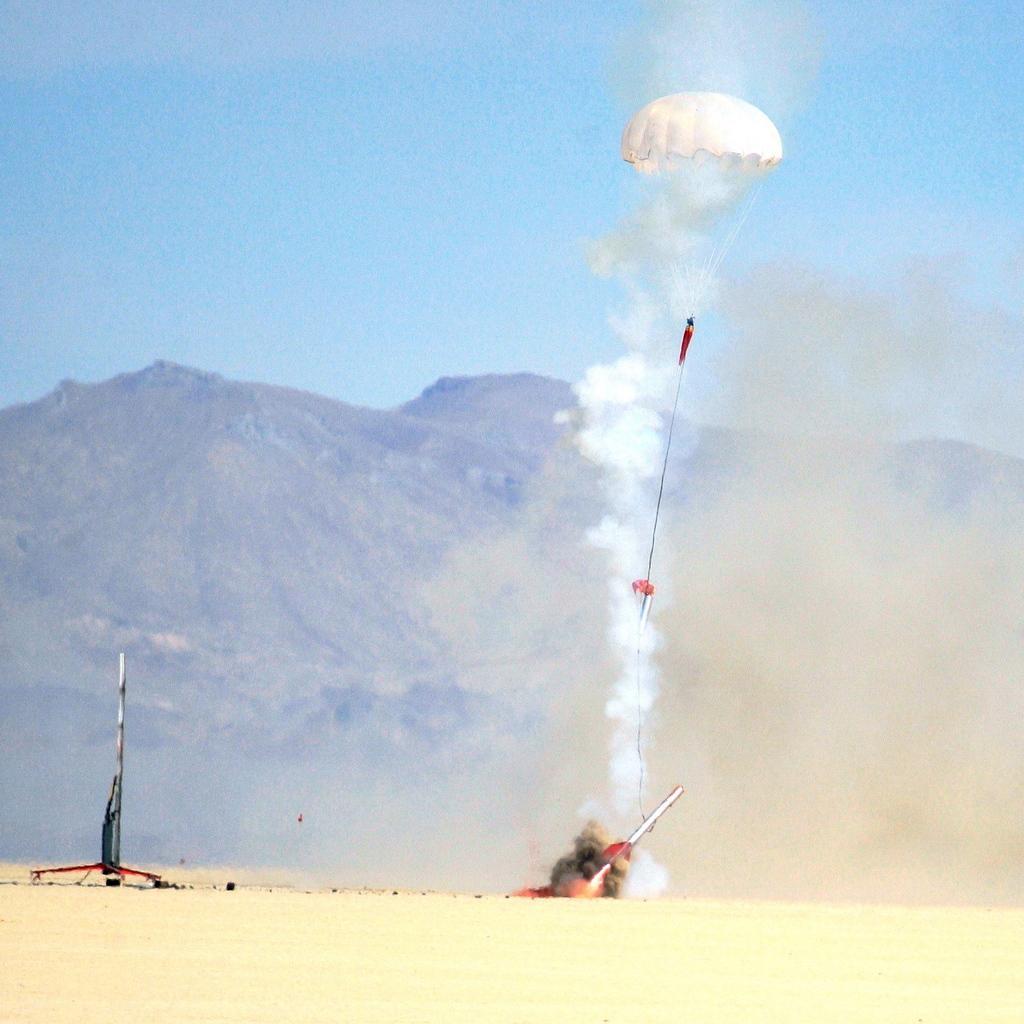In one or two sentences, can you explain what this image depicts? In this image we can see a parachute tied to a plane. We can see the smoke coming from a plane. There is a plane on the left side on the land. On the backside we can see some mountains and the sky. 